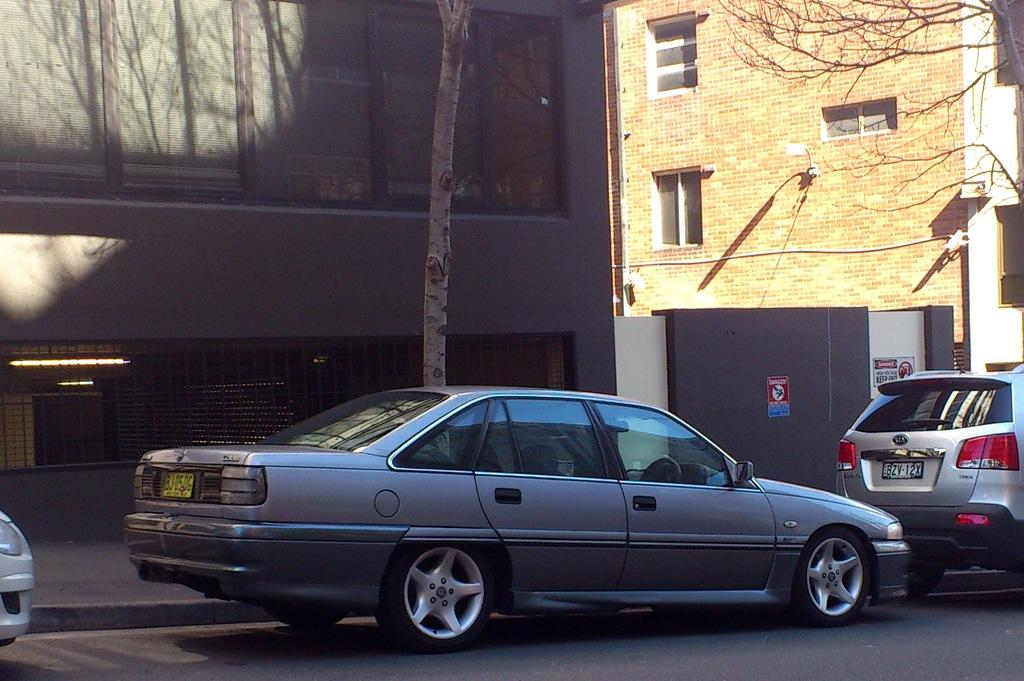What can be found in the parking space in the image? There are vehicles in the parking space in the image. What type of natural elements can be seen in the image? Trees are visible in the image. What type of man-made structures are present in the image? There are buildings in the image. Can you see the moon in the image? No, the moon is not visible in the image. Is there a basin in the image? There is no basin present in the image. 